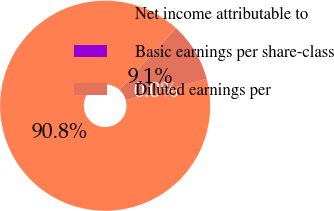Convert chart to OTSL. <chart><loc_0><loc_0><loc_500><loc_500><pie_chart><fcel>Net income attributable to<fcel>Basic earnings per share-class<fcel>Diluted earnings per<nl><fcel>90.85%<fcel>0.03%<fcel>9.12%<nl></chart> 